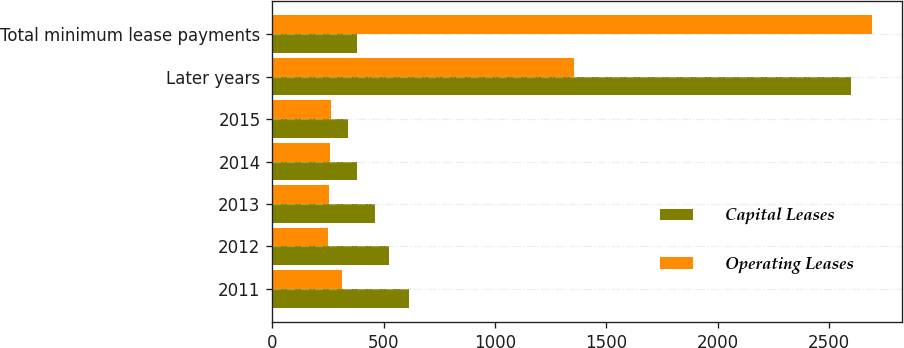Convert chart. <chart><loc_0><loc_0><loc_500><loc_500><stacked_bar_chart><ecel><fcel>2011<fcel>2012<fcel>2013<fcel>2014<fcel>2015<fcel>Later years<fcel>Total minimum lease payments<nl><fcel>Capital Leases<fcel>613<fcel>526<fcel>461<fcel>382<fcel>340<fcel>2599<fcel>382<nl><fcel>Operating Leases<fcel>311<fcel>251<fcel>253<fcel>261<fcel>262<fcel>1355<fcel>2693<nl></chart> 